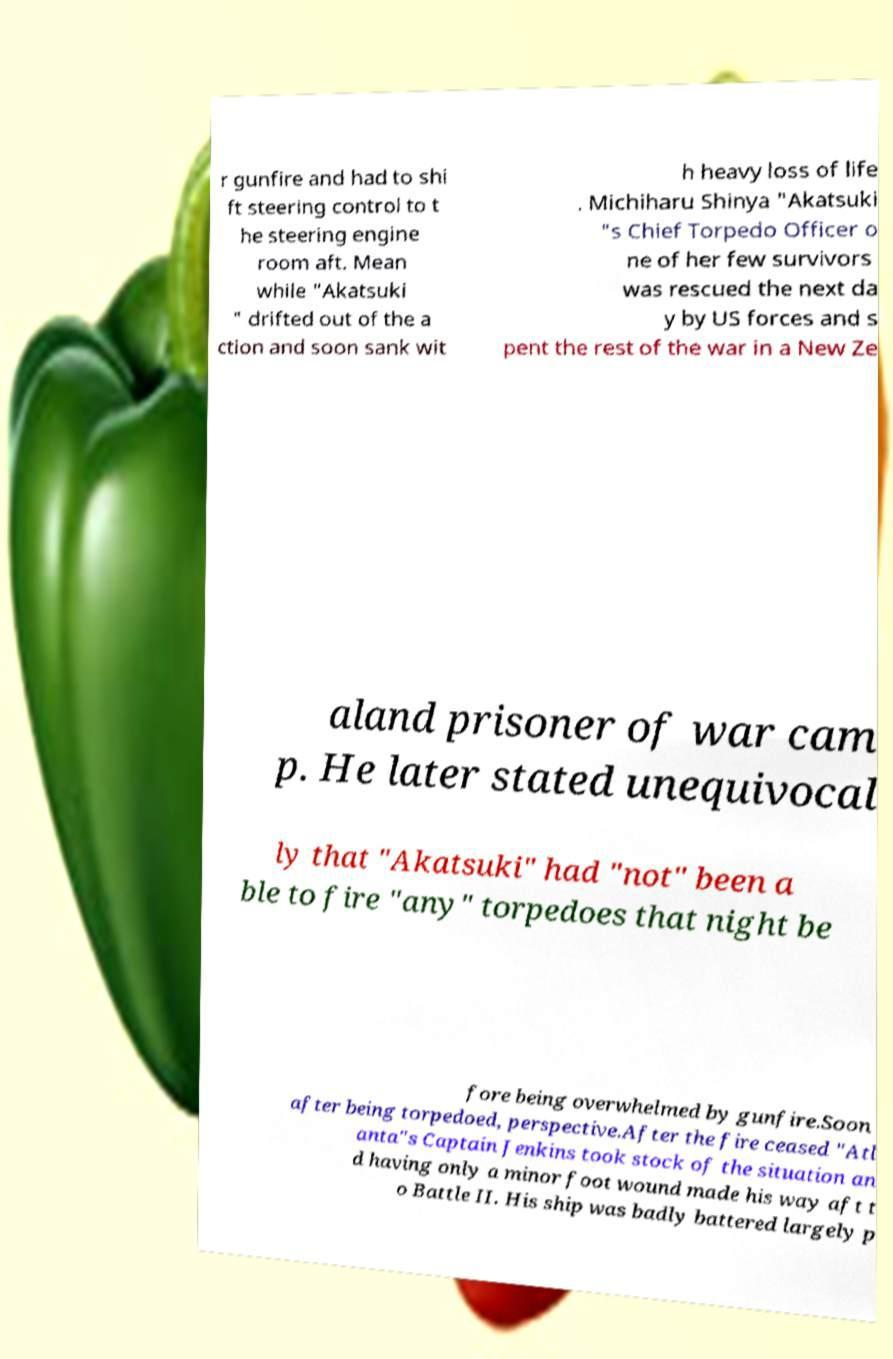Please identify and transcribe the text found in this image. r gunfire and had to shi ft steering control to t he steering engine room aft. Mean while "Akatsuki " drifted out of the a ction and soon sank wit h heavy loss of life . Michiharu Shinya "Akatsuki "s Chief Torpedo Officer o ne of her few survivors was rescued the next da y by US forces and s pent the rest of the war in a New Ze aland prisoner of war cam p. He later stated unequivocal ly that "Akatsuki" had "not" been a ble to fire "any" torpedoes that night be fore being overwhelmed by gunfire.Soon after being torpedoed, perspective.After the fire ceased "Atl anta"s Captain Jenkins took stock of the situation an d having only a minor foot wound made his way aft t o Battle II. His ship was badly battered largely p 